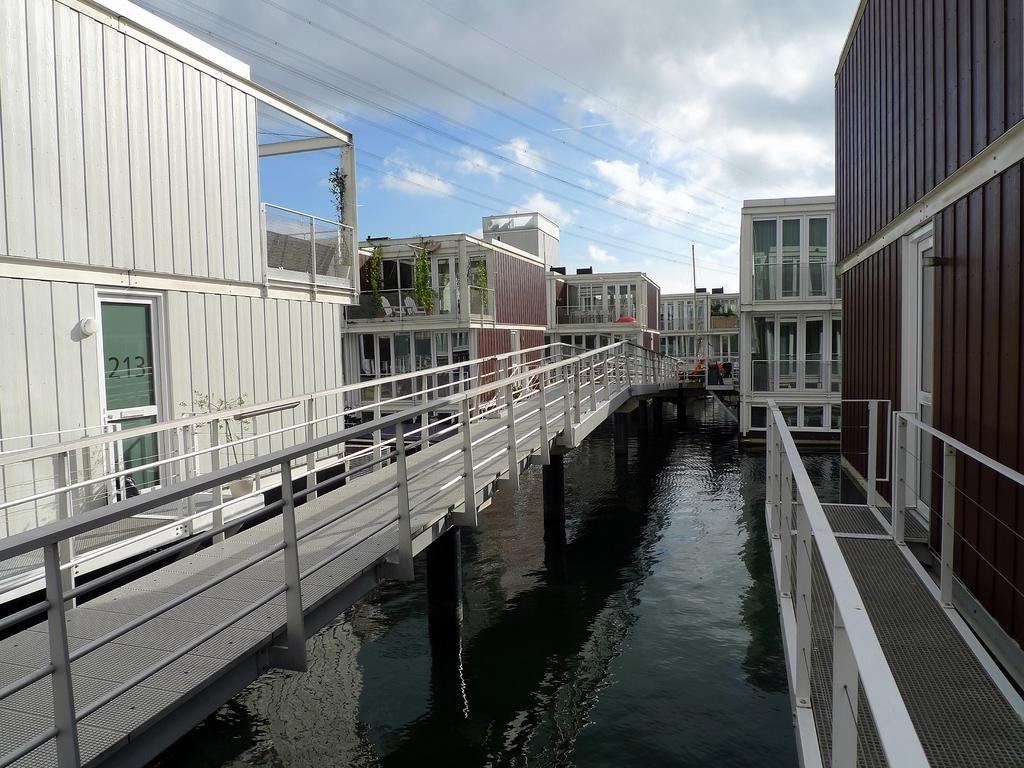What type of water feature is present in the image? There is a canal in the image. How can someone cross the canal in the image? There is a bridge across the canal in the image. What structures are located near the canal? There are buildings on either side of the canal. What else can be seen in the background of the image? There are wires and the sky visible in the background. Can you see the tongue of the person who took the picture in the image? There is no person or tongue visible in the image. Is there an island in the middle of the canal in the image? There is no island present in the image; it features a canal with a bridge and buildings on either side. 